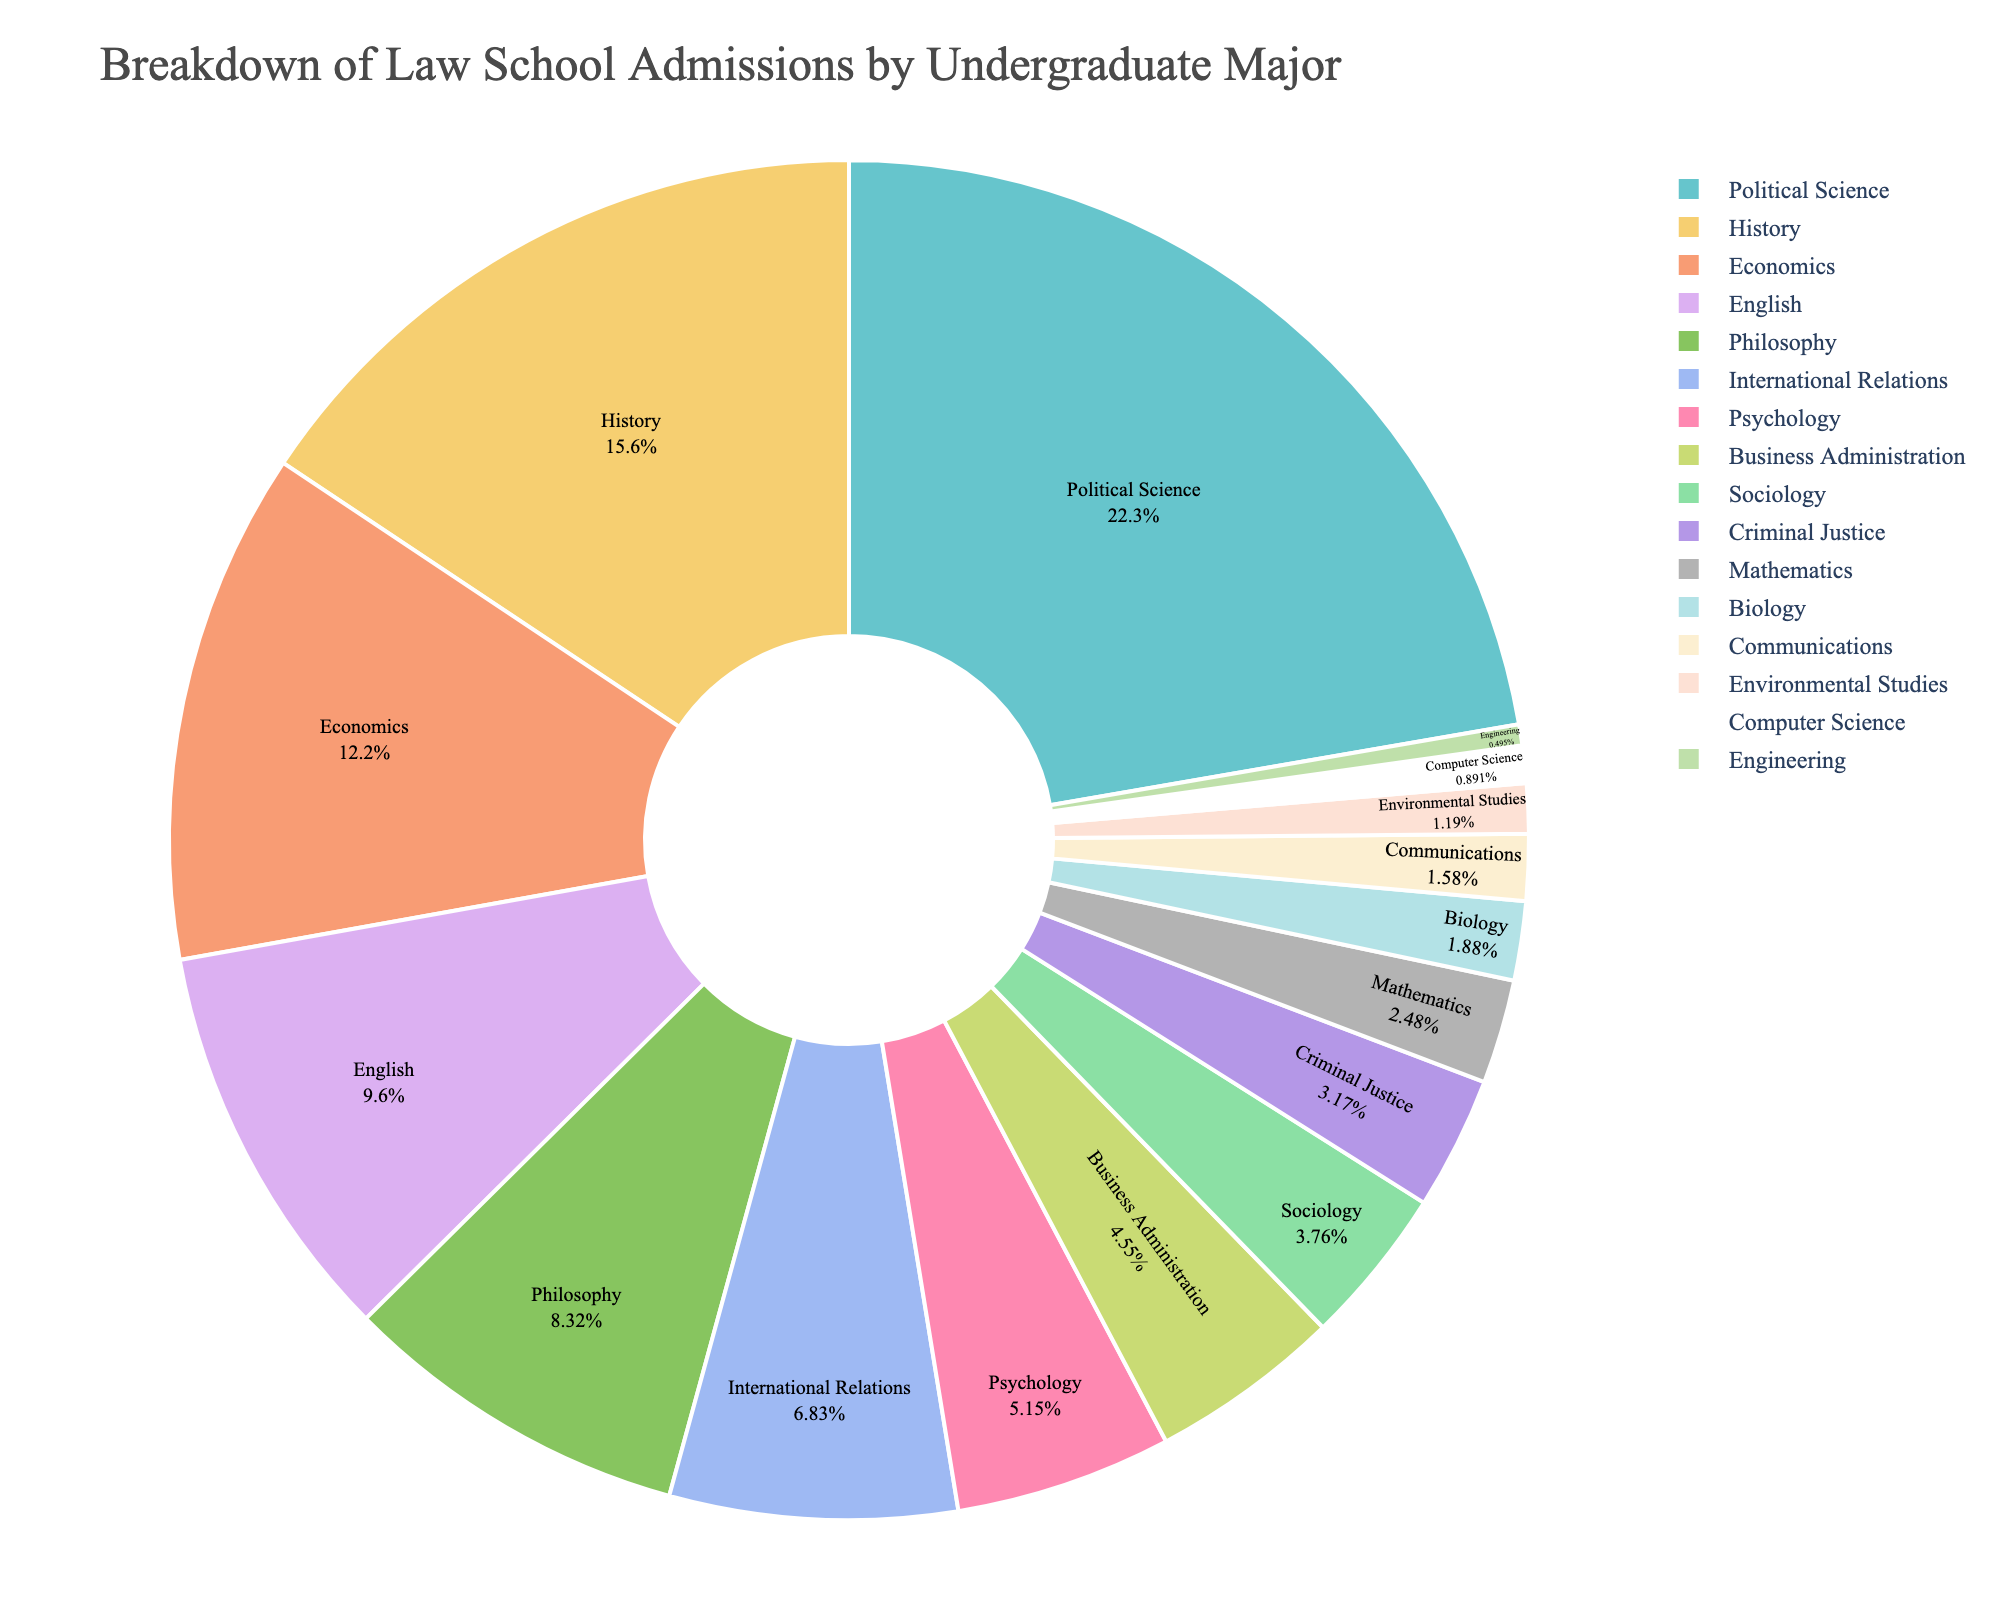Which undergraduate major has the highest percentage of law school admissions? The major with the highest percentage is the one with the largest slice of the pie chart. Political Science is listed with the highest percentage.
Answer: Political Science What is the total percentage of law school admissions contributed by Political Science, History, and Economics combined? To find the total percentage, add the percentages of Political Science (22.5%), History (15.8%), and Economics (12.3%) together: 22.5 + 15.8 + 12.3 = 50.6%
Answer: 50.6% How does the percentage of law school admissions for Psychology compare to that of Criminal Justice? To compare the percentages, look at the slices labeled Psychology (5.2%) and Criminal Justice (3.2%) on the pie chart. Psychology has a higher percentage than Criminal Justice.
Answer: Psychology has a higher percentage Which major has a lower percentage of admissions than Communications but higher than Engineering? Look at the slices labeled Communications (1.6%) and Engineering (0.5%). The major that falls between these two percentages is Environmental Studies with 1.2%.
Answer: Environmental Studies What is the combined percentage of law school admissions for Philosophy and International Relations? Add the percentages of Philosophy (8.4%) and International Relations (6.9%): 8.4 + 6.9 = 15.3%
Answer: 15.3% Rank the top three undergraduate majors by their percentage of law school admissions. The top three slices with the highest percentages are Political Science (22.5%), History (15.8%), and Economics (12.3%).
Answer: Political Science, History, Economics What is the difference in percentage points between Business Administration and Sociology? Subtract the percentage of Sociology (3.8%) from Business Administration (4.6%): 4.6 - 3.8 = 0.8 percentage points
Answer: 0.8 percentage points Which majors have a percentage less than 2%? Look at the slices with percentages less than 2%, which are Biology (1.9%), Communications (1.6%), Environmental Studies (1.2%), Computer Science (0.9%), and Engineering (0.5%).
Answer: Biology, Communications, Environmental Studies, Computer Science, Engineering 